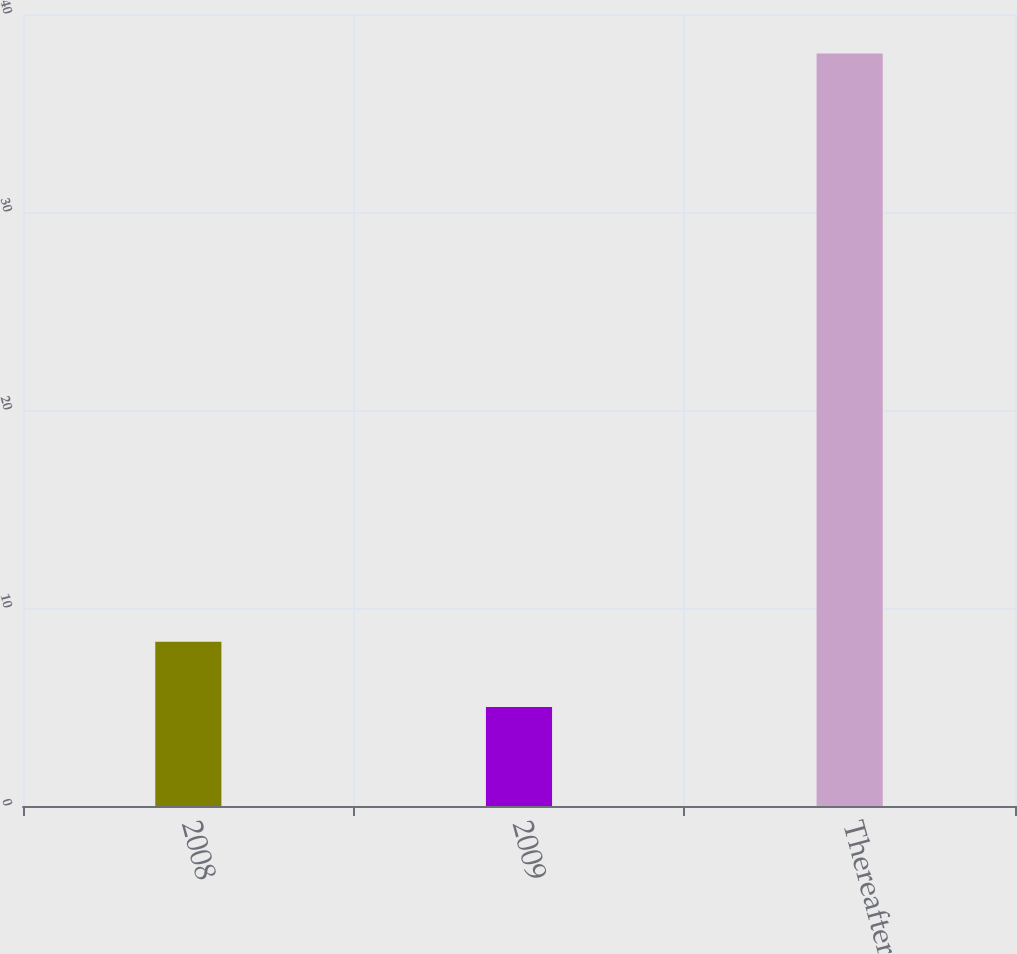Convert chart to OTSL. <chart><loc_0><loc_0><loc_500><loc_500><bar_chart><fcel>2008<fcel>2009<fcel>Thereafter<nl><fcel>8.3<fcel>5<fcel>38<nl></chart> 